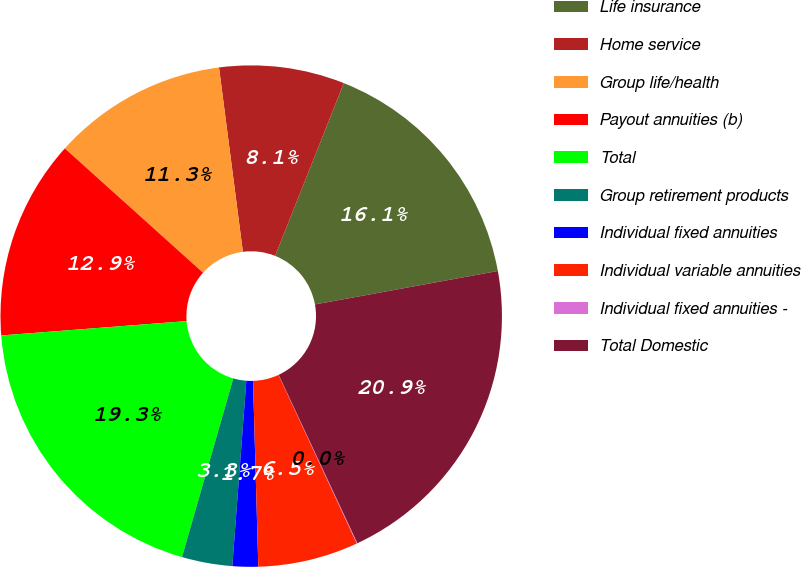<chart> <loc_0><loc_0><loc_500><loc_500><pie_chart><fcel>Life insurance<fcel>Home service<fcel>Group life/health<fcel>Payout annuities (b)<fcel>Total<fcel>Group retirement products<fcel>Individual fixed annuities<fcel>Individual variable annuities<fcel>Individual fixed annuities -<fcel>Total Domestic<nl><fcel>16.1%<fcel>8.07%<fcel>11.29%<fcel>12.89%<fcel>19.32%<fcel>3.25%<fcel>1.65%<fcel>6.47%<fcel>0.04%<fcel>20.92%<nl></chart> 